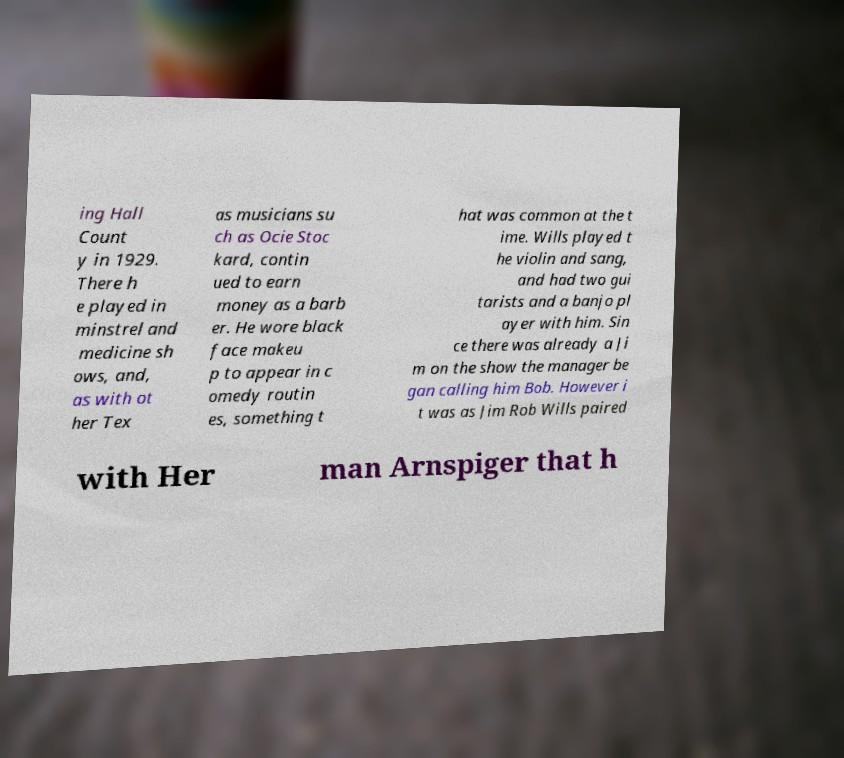Please identify and transcribe the text found in this image. ing Hall Count y in 1929. There h e played in minstrel and medicine sh ows, and, as with ot her Tex as musicians su ch as Ocie Stoc kard, contin ued to earn money as a barb er. He wore black face makeu p to appear in c omedy routin es, something t hat was common at the t ime. Wills played t he violin and sang, and had two gui tarists and a banjo pl ayer with him. Sin ce there was already a Ji m on the show the manager be gan calling him Bob. However i t was as Jim Rob Wills paired with Her man Arnspiger that h 